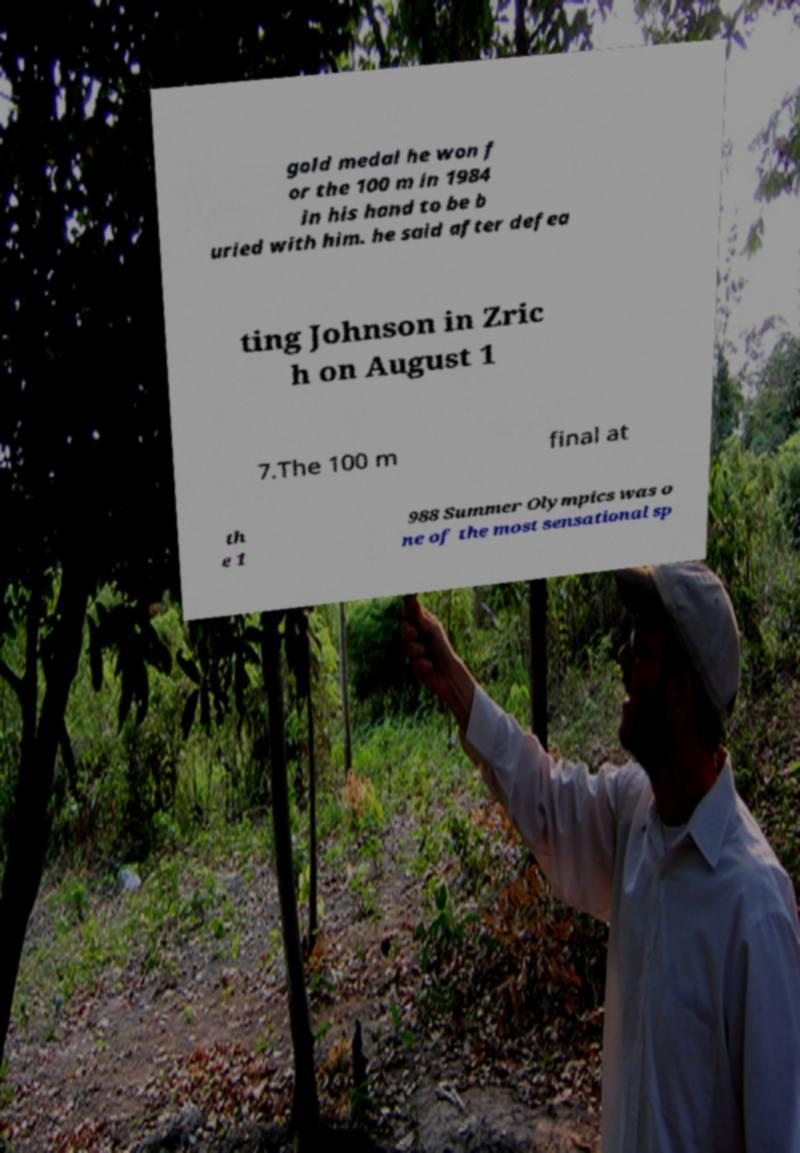Please read and relay the text visible in this image. What does it say? gold medal he won f or the 100 m in 1984 in his hand to be b uried with him. he said after defea ting Johnson in Zric h on August 1 7.The 100 m final at th e 1 988 Summer Olympics was o ne of the most sensational sp 